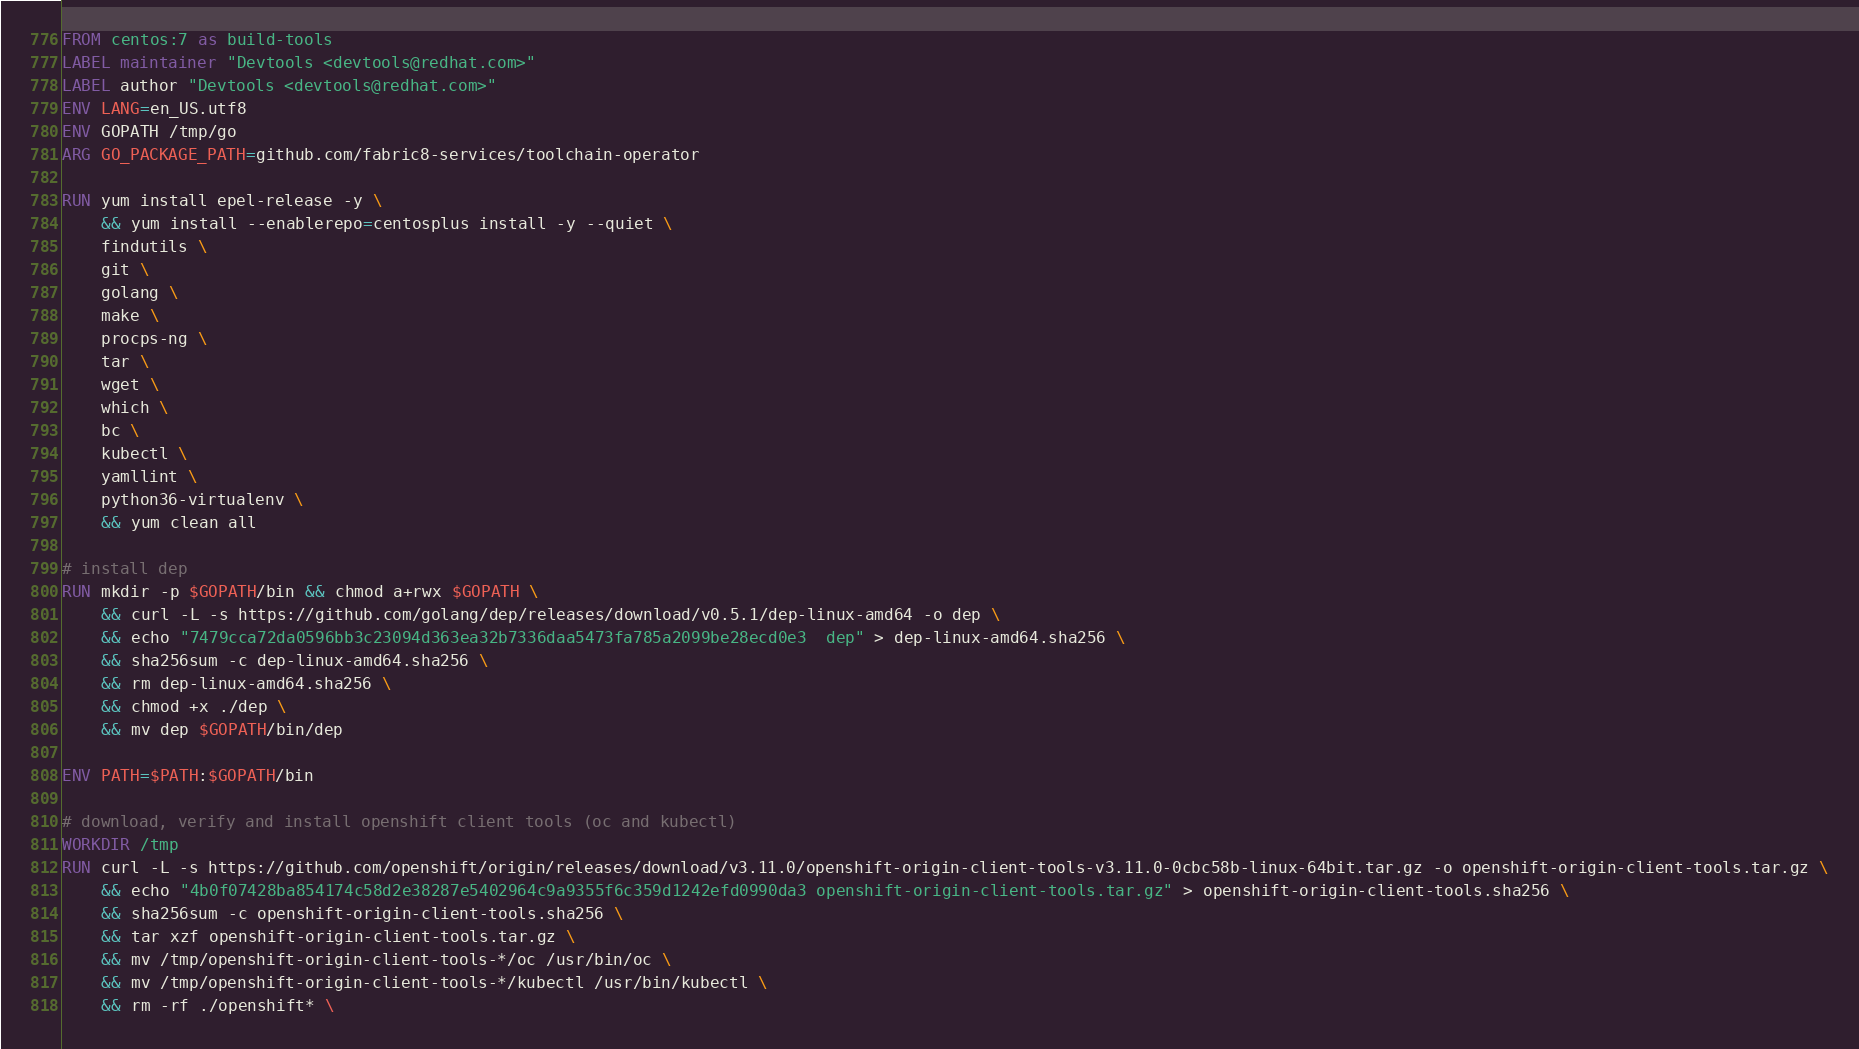<code> <loc_0><loc_0><loc_500><loc_500><_Dockerfile_>FROM centos:7 as build-tools
LABEL maintainer "Devtools <devtools@redhat.com>"
LABEL author "Devtools <devtools@redhat.com>"
ENV LANG=en_US.utf8
ENV GOPATH /tmp/go
ARG GO_PACKAGE_PATH=github.com/fabric8-services/toolchain-operator

RUN yum install epel-release -y \
    && yum install --enablerepo=centosplus install -y --quiet \
    findutils \
    git \
    golang \
    make \
    procps-ng \
    tar \
    wget \
    which \
    bc \
    kubectl \
    yamllint \
    python36-virtualenv \
    && yum clean all

# install dep
RUN mkdir -p $GOPATH/bin && chmod a+rwx $GOPATH \
    && curl -L -s https://github.com/golang/dep/releases/download/v0.5.1/dep-linux-amd64 -o dep \
    && echo "7479cca72da0596bb3c23094d363ea32b7336daa5473fa785a2099be28ecd0e3  dep" > dep-linux-amd64.sha256 \
    && sha256sum -c dep-linux-amd64.sha256 \
    && rm dep-linux-amd64.sha256 \
    && chmod +x ./dep \
    && mv dep $GOPATH/bin/dep

ENV PATH=$PATH:$GOPATH/bin

# download, verify and install openshift client tools (oc and kubectl)
WORKDIR /tmp
RUN curl -L -s https://github.com/openshift/origin/releases/download/v3.11.0/openshift-origin-client-tools-v3.11.0-0cbc58b-linux-64bit.tar.gz -o openshift-origin-client-tools.tar.gz \
    && echo "4b0f07428ba854174c58d2e38287e5402964c9a9355f6c359d1242efd0990da3 openshift-origin-client-tools.tar.gz" > openshift-origin-client-tools.sha256 \
    && sha256sum -c openshift-origin-client-tools.sha256 \
    && tar xzf openshift-origin-client-tools.tar.gz \
    && mv /tmp/openshift-origin-client-tools-*/oc /usr/bin/oc \
    && mv /tmp/openshift-origin-client-tools-*/kubectl /usr/bin/kubectl \
    && rm -rf ./openshift* \</code> 